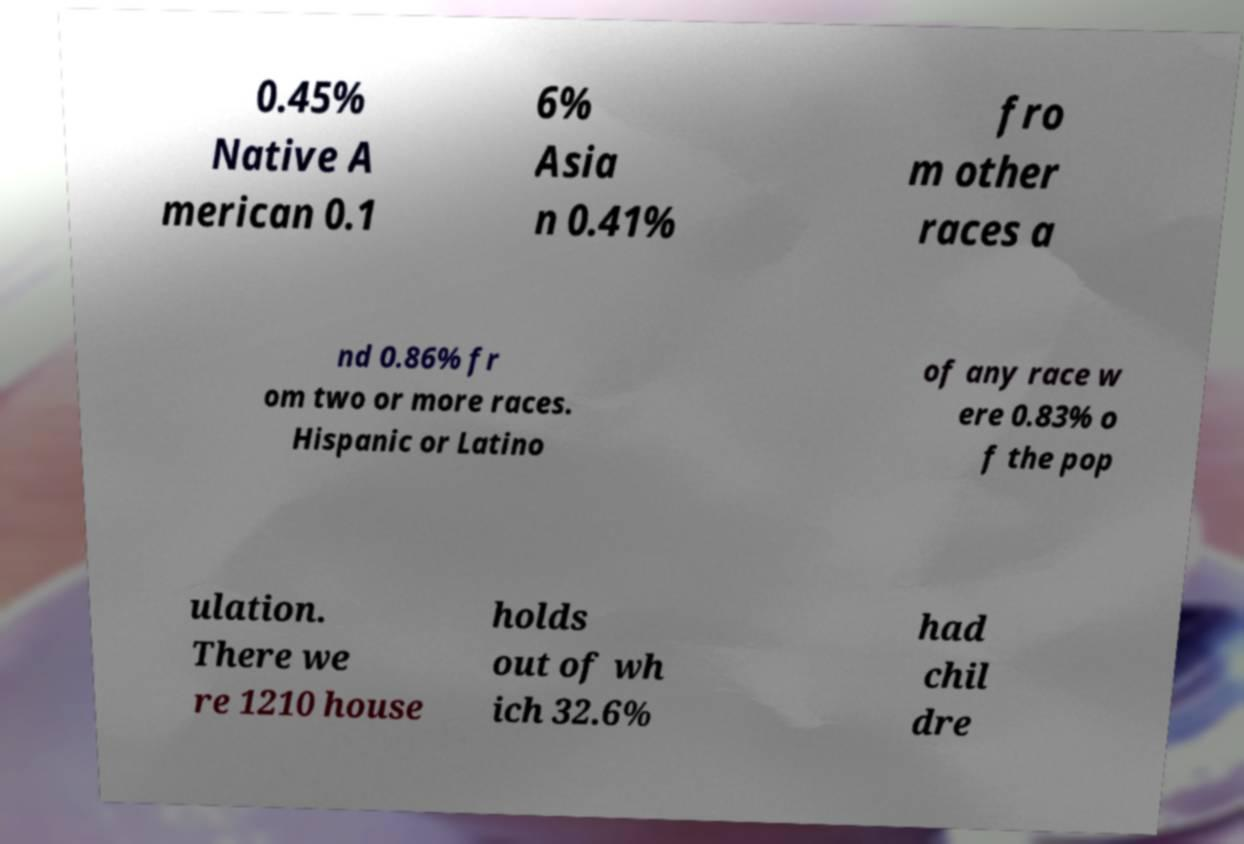Please identify and transcribe the text found in this image. 0.45% Native A merican 0.1 6% Asia n 0.41% fro m other races a nd 0.86% fr om two or more races. Hispanic or Latino of any race w ere 0.83% o f the pop ulation. There we re 1210 house holds out of wh ich 32.6% had chil dre 